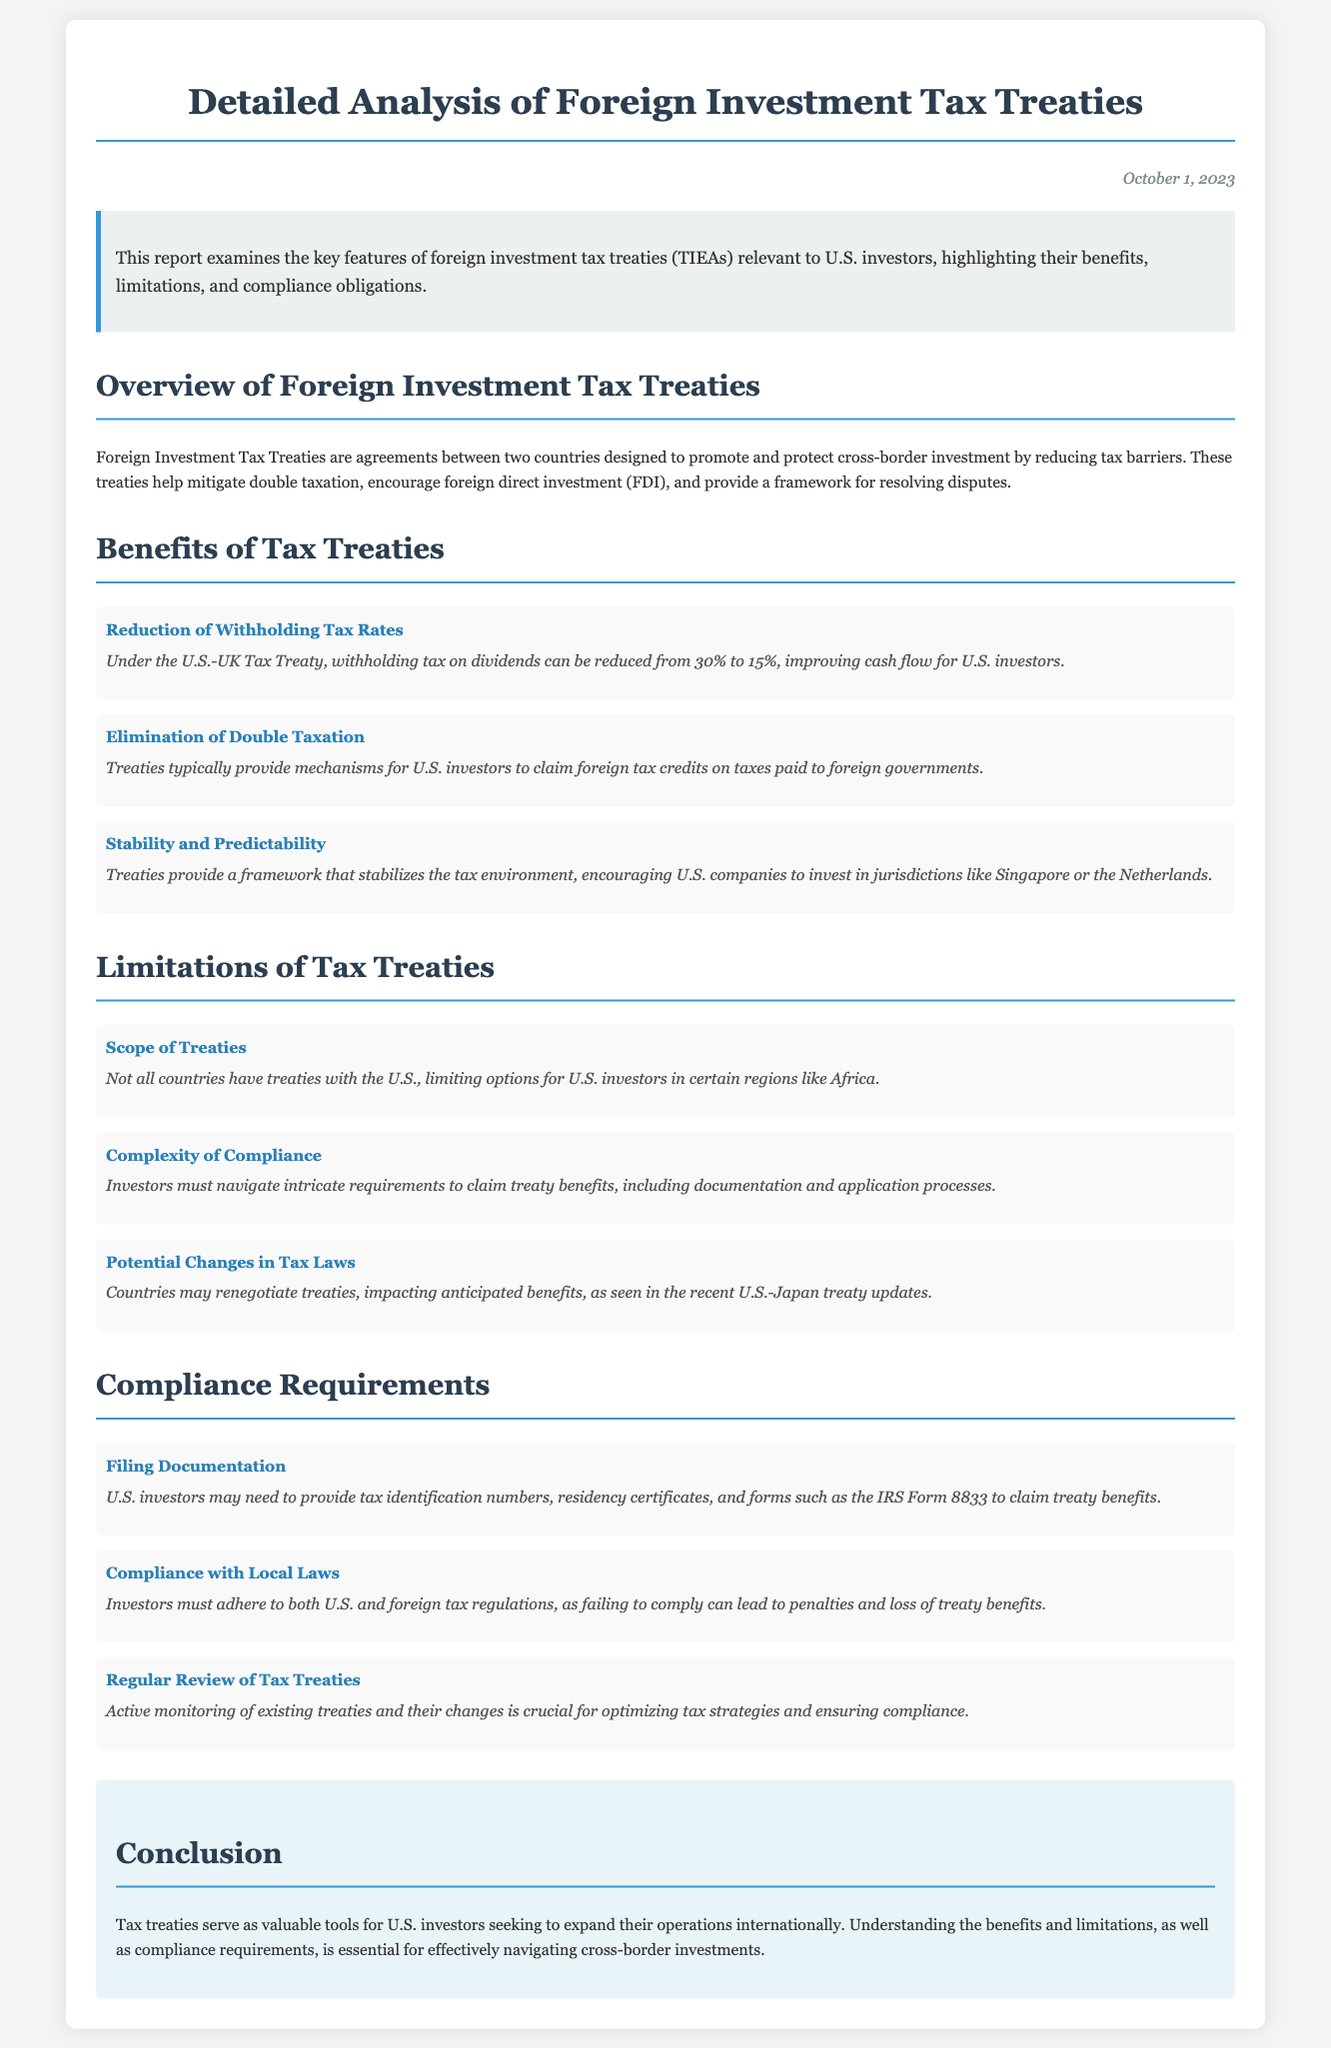What is the title of the report? The title of the report is clearly stated at the top of the document, which is "Detailed Analysis of Foreign Investment Tax Treaties."
Answer: Detailed Analysis of Foreign Investment Tax Treaties When was the report published? The publication date is indicated at the top right corner of the document, listed as "October 1, 2023."
Answer: October 1, 2023 What is one benefit of tax treaties mentioned? The document lists multiple benefits, one of which is the "Reduction of Withholding Tax Rates."
Answer: Reduction of Withholding Tax Rates What is a limitation of tax treaties? The document outlines several limitations, including "Scope of Treaties."
Answer: Scope of Treaties What is a compliance requirement for U.S. investors? The report lists multiple requirements, one being "Filing Documentation."
Answer: Filing Documentation How can investors claim foreign tax credits? The report mentions a mechanism provided in treaties, specifically indicating that it "provides mechanisms for U.S. investors to claim foreign tax credits."
Answer: Claim foreign tax credits What countries are highlighted as having a stable tax environment? Specific countries are mentioned as examples of stable environments, such as "Singapore or the Netherlands."
Answer: Singapore or the Netherlands What is the purpose of Foreign Investment Tax Treaties? The purpose of these treaties is outlined in the introduction as "to promote and protect cross-border investment by reducing tax barriers."
Answer: To promote and protect cross-border investment by reducing tax barriers What forms might U.S. investors need to file? The document specifically mentions "IRS Form 8833" as part of the filing documentation required to claim treaty benefits.
Answer: IRS Form 8833 